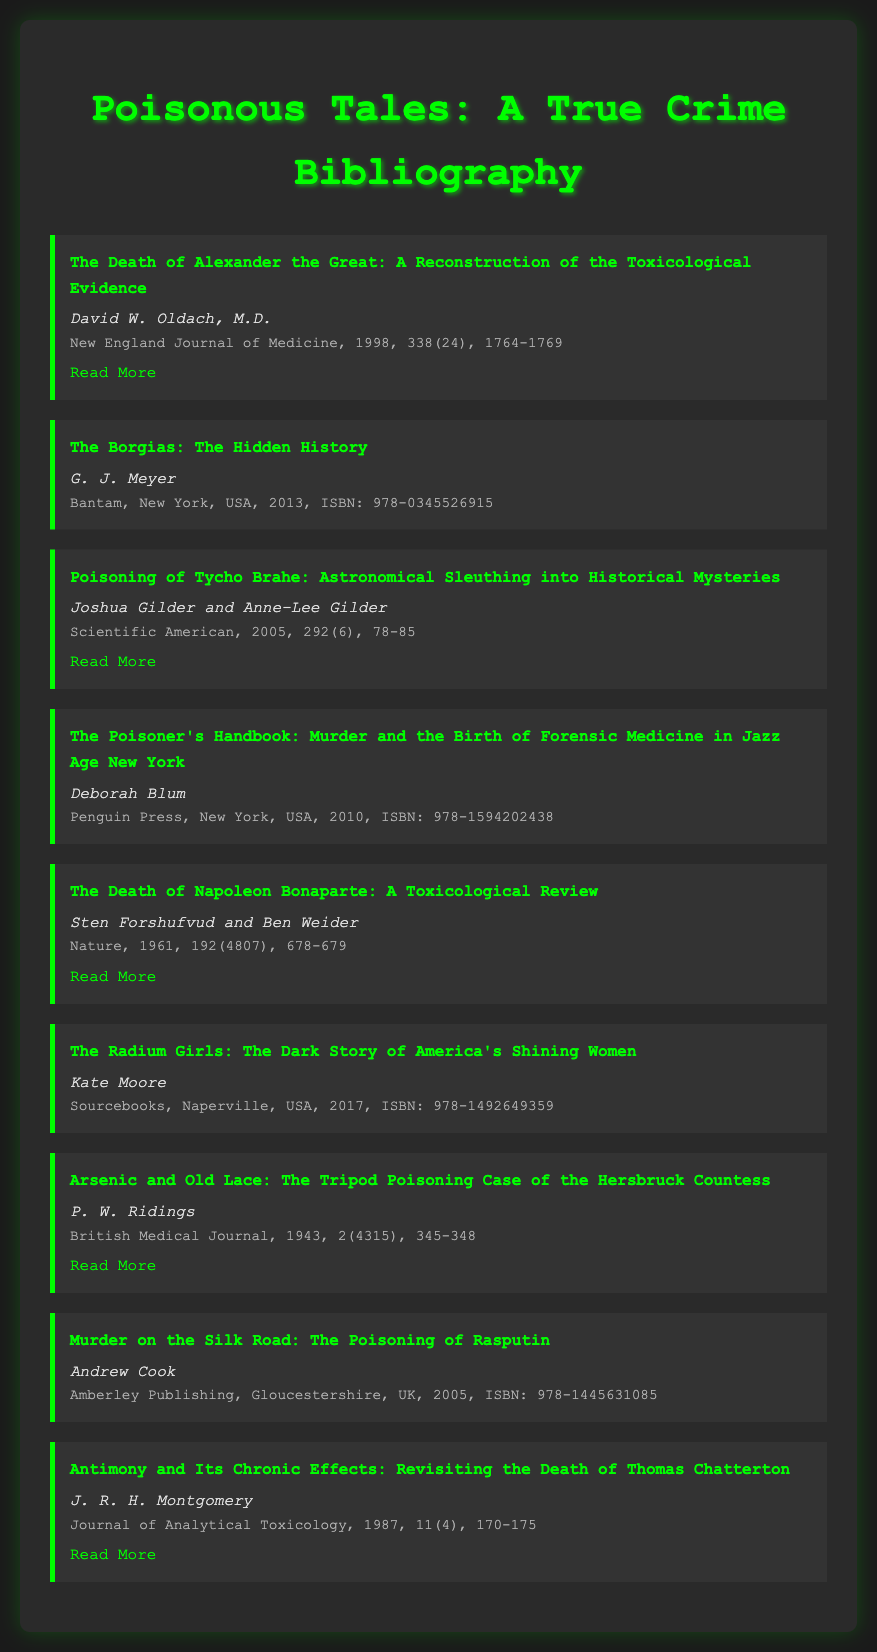What is the title of the first item in the bibliography? The title is found at the top of the first bibliography entry.
Answer: The Death of Alexander the Great: A Reconstruction of the Toxicological Evidence Who is the author of "The Poisoner's Handbook"? The author is listed under the title in the corresponding entry.
Answer: Deborah Blum What is the publication year of "The Borgias: The Hidden History"? The publication year is provided in the details section of the bibliography item.
Answer: 2013 How many pages does the document mention for "The Death of Napoleon Bonaparte: A Toxicological Review"? The page range is included in the details section of the entry related to this document.
Answer: 678-679 Which journal published the article on the poisoning of Tycho Brahe? The name of the journal can be found in the details section of the bibliography entry.
Answer: Scientific American What is the ISBN of "The Radium Girls: The Dark Story of America's Shining Women"? ISBN numbers are provided alongside the publication details of the listed items.
Answer: 978-1492649359 How many authors contributed to the piece on the death of Thomas Chatterton? The number of authors can be determined by examining the author field in that bibliography entry.
Answer: One Which city is associated with the publisher of "Murder on the Silk Road"? The city of publication is provided within the bibliographic details.
Answer: Gloucestershire 